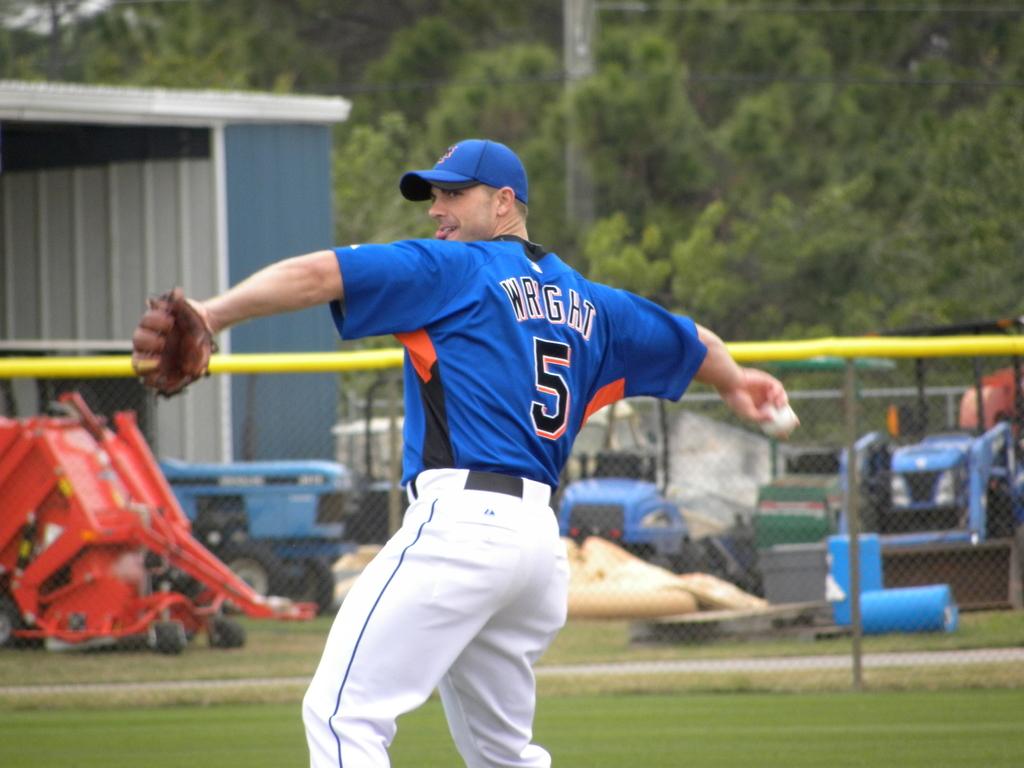What is the name of the baseball player?
Provide a short and direct response. Wright. What number is wright?
Give a very brief answer. 5. 